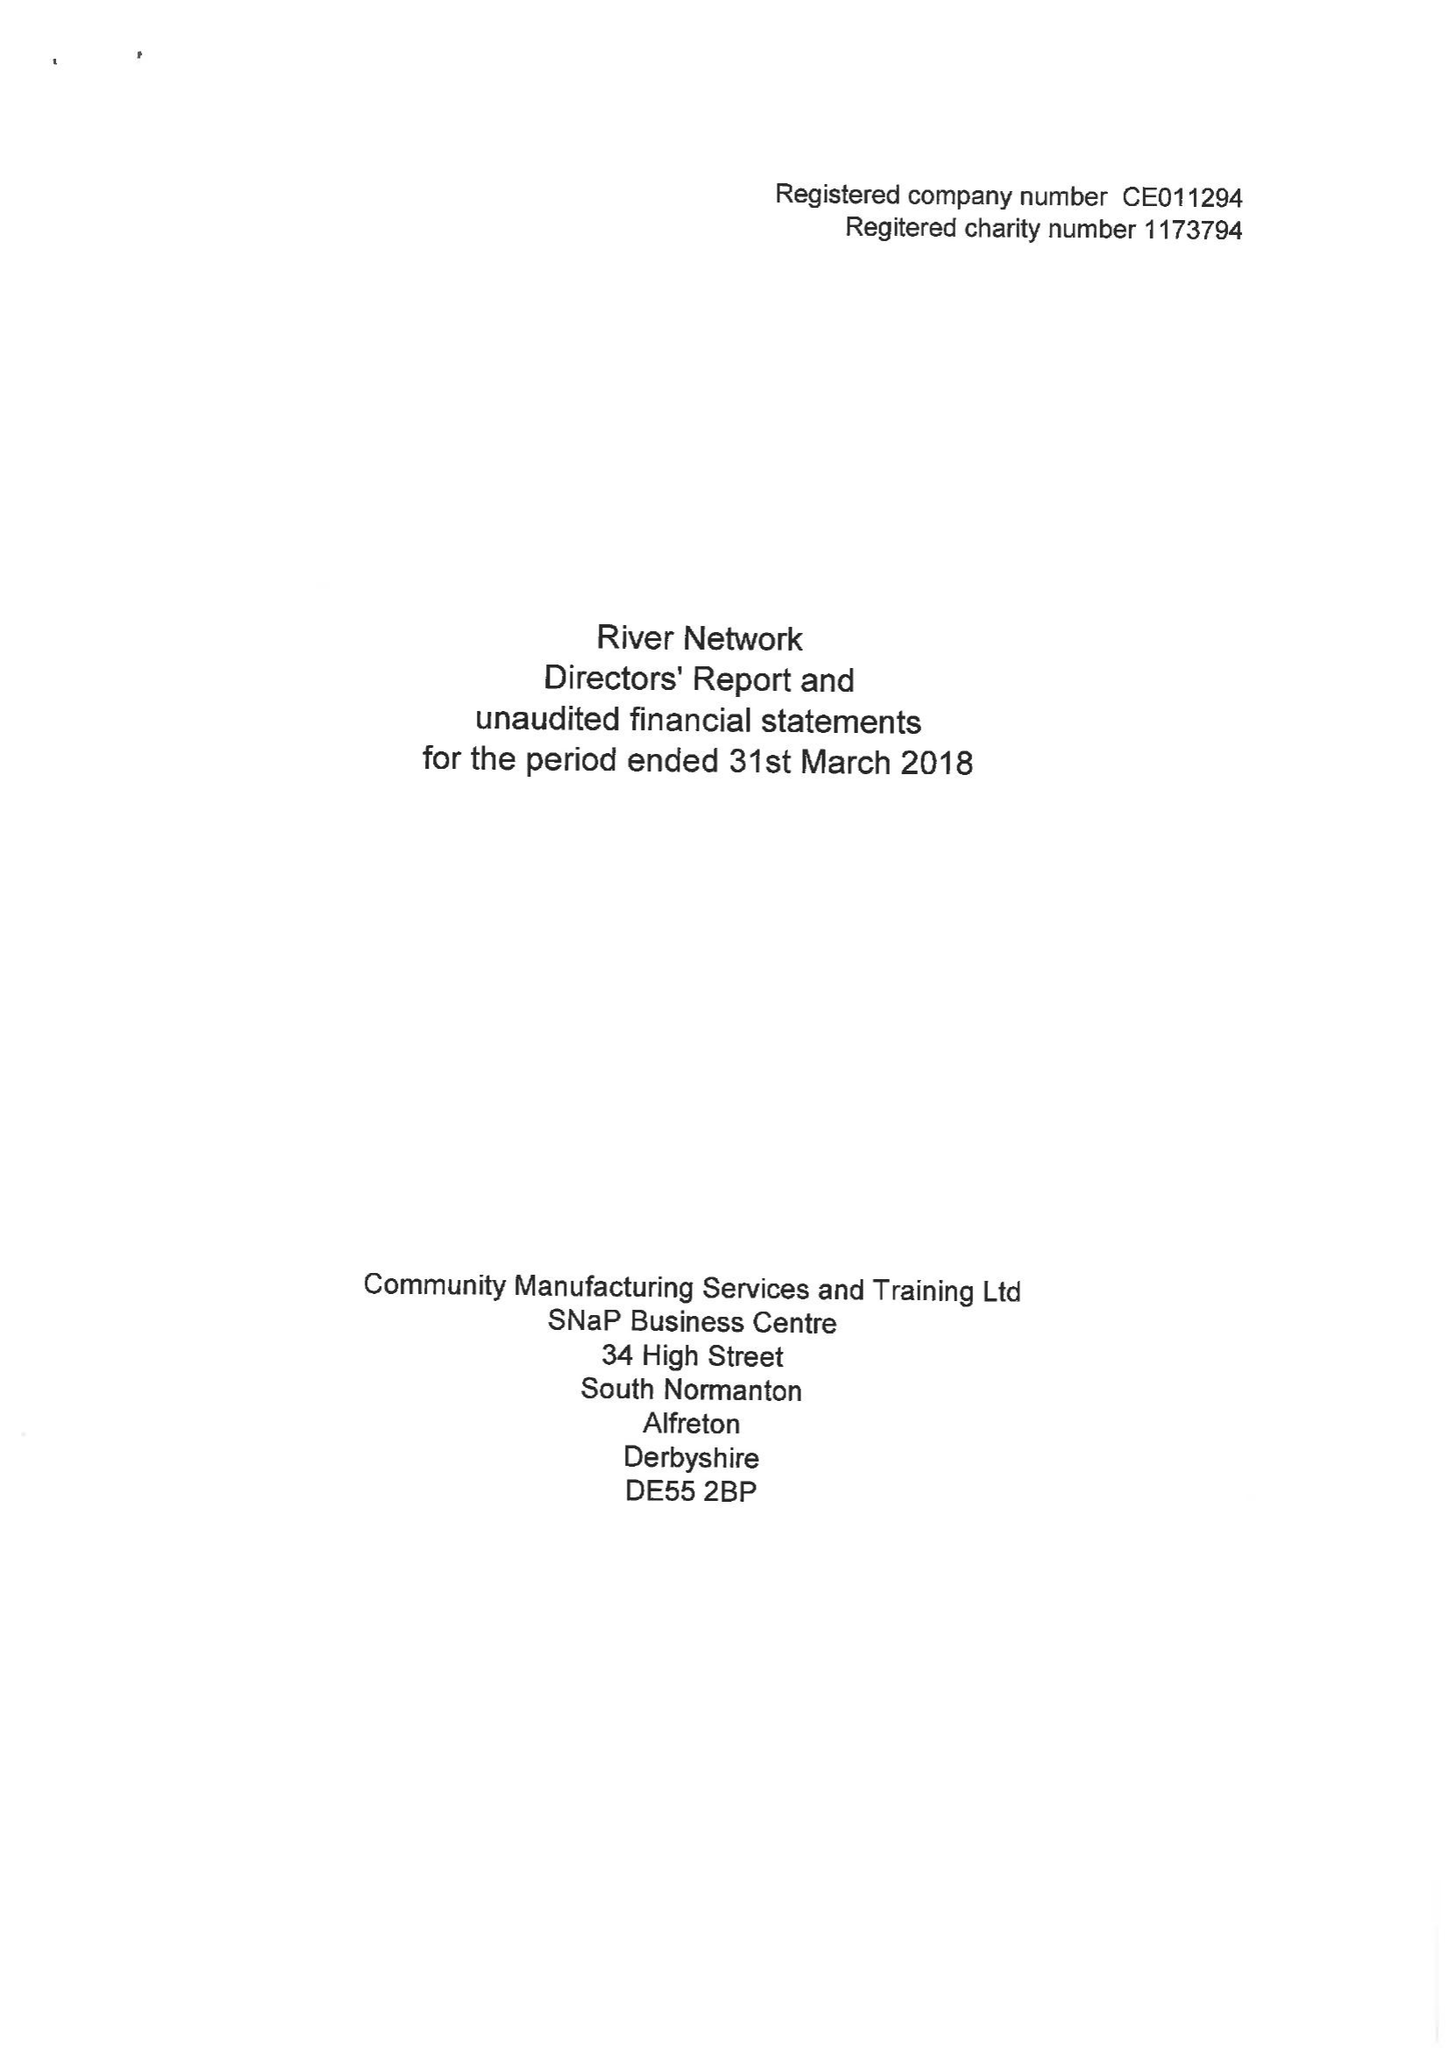What is the value for the address__postcode?
Answer the question using a single word or phrase. None 